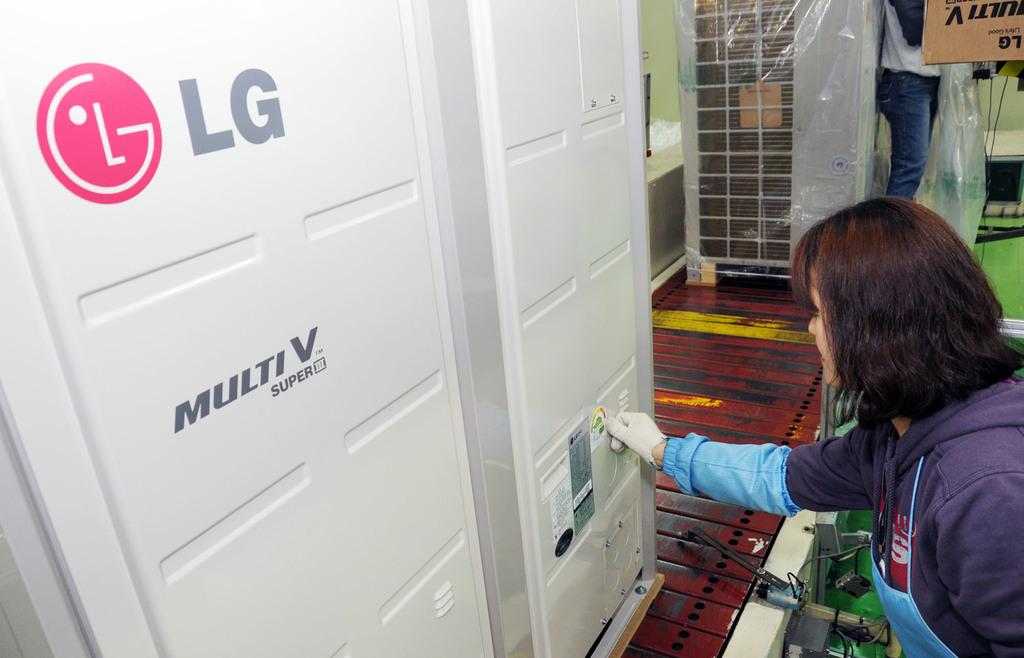What brand is this?
Make the answer very short. Lg. What is the label word under multi v?
Offer a very short reply. Super. 